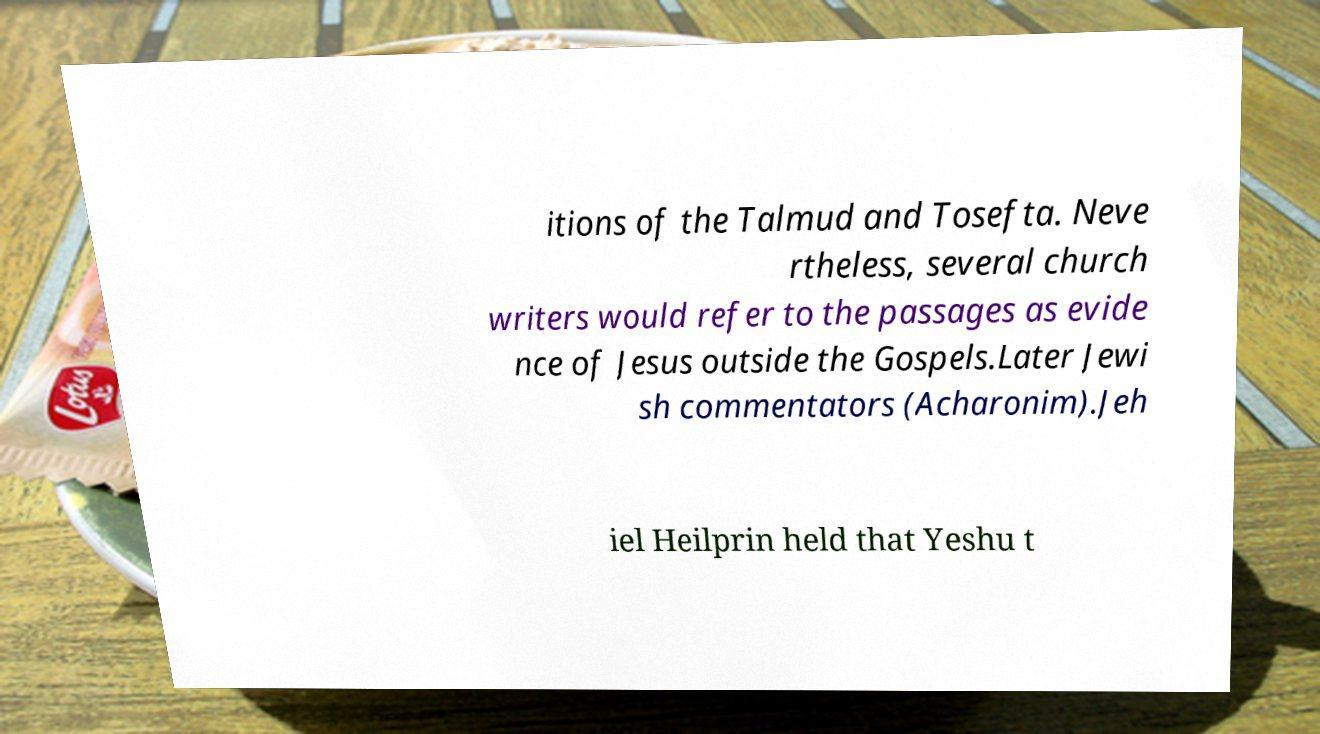I need the written content from this picture converted into text. Can you do that? itions of the Talmud and Tosefta. Neve rtheless, several church writers would refer to the passages as evide nce of Jesus outside the Gospels.Later Jewi sh commentators (Acharonim).Jeh iel Heilprin held that Yeshu t 